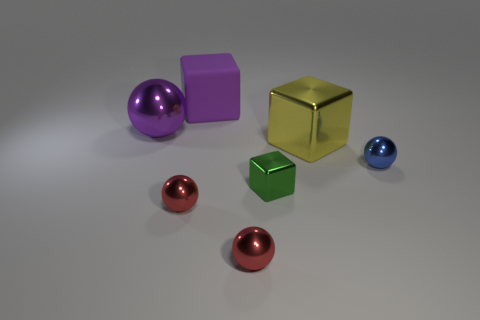Is there another metallic object of the same shape as the big yellow metallic thing?
Your response must be concise. Yes. There is a purple shiny thing that is the same size as the yellow shiny thing; what shape is it?
Your answer should be very brief. Sphere. What is the material of the big purple ball?
Give a very brief answer. Metal. How big is the cube that is in front of the small shiny thing on the right side of the metal block in front of the blue thing?
Your response must be concise. Small. There is a ball that is the same color as the large matte object; what material is it?
Make the answer very short. Metal. How many metal things are either purple spheres or big purple cylinders?
Keep it short and to the point. 1. The green thing is what size?
Your answer should be very brief. Small. What number of objects are either tiny green blocks or cubes in front of the big metallic ball?
Keep it short and to the point. 2. What number of other objects are the same color as the small cube?
Keep it short and to the point. 0. Is the size of the blue thing the same as the cube that is left of the tiny green shiny cube?
Offer a terse response. No. 